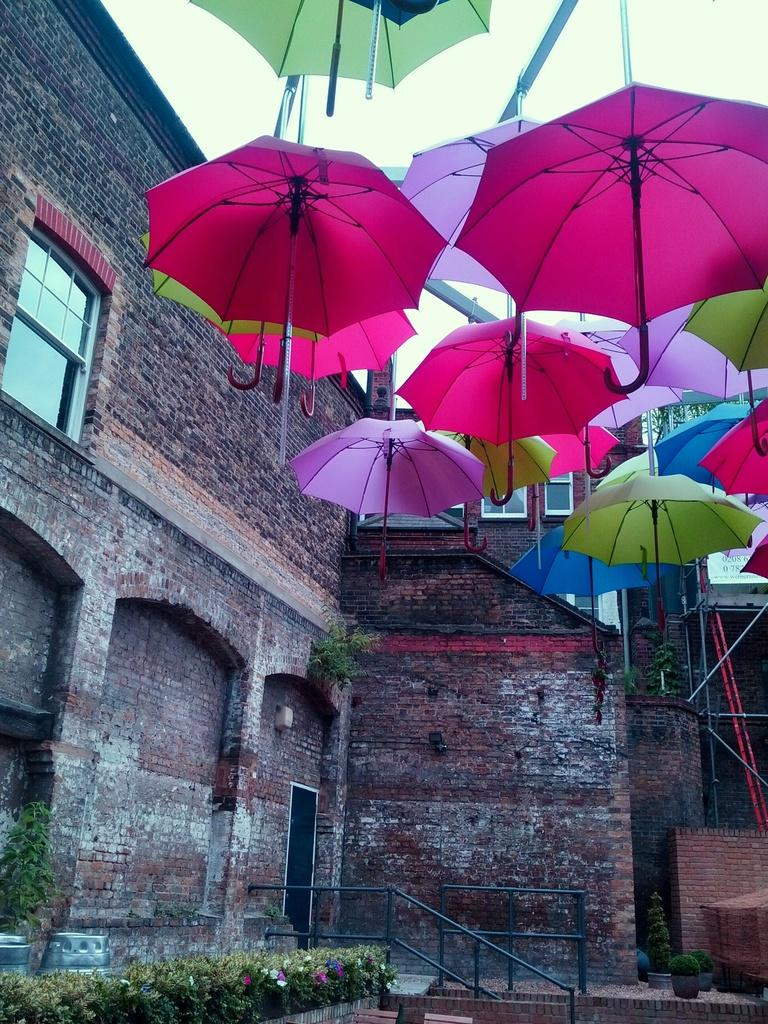What is hanging down from the roof in the image? Umbrellas are hanging down from the roof in the image. What type of building is shown in the image? There is a building with a glass window in the image. What can be seen at the bottom of the image? Plants are visible at the bottom of the image. What might be used for safety or support at the bottom of the image? There is a railing at the bottom of the image. Where is the tray placed in the image? There is no tray present in the image. What type of polish is being applied to the plants in the image? There is no polish being applied to the plants in the image; they are simply visible. 